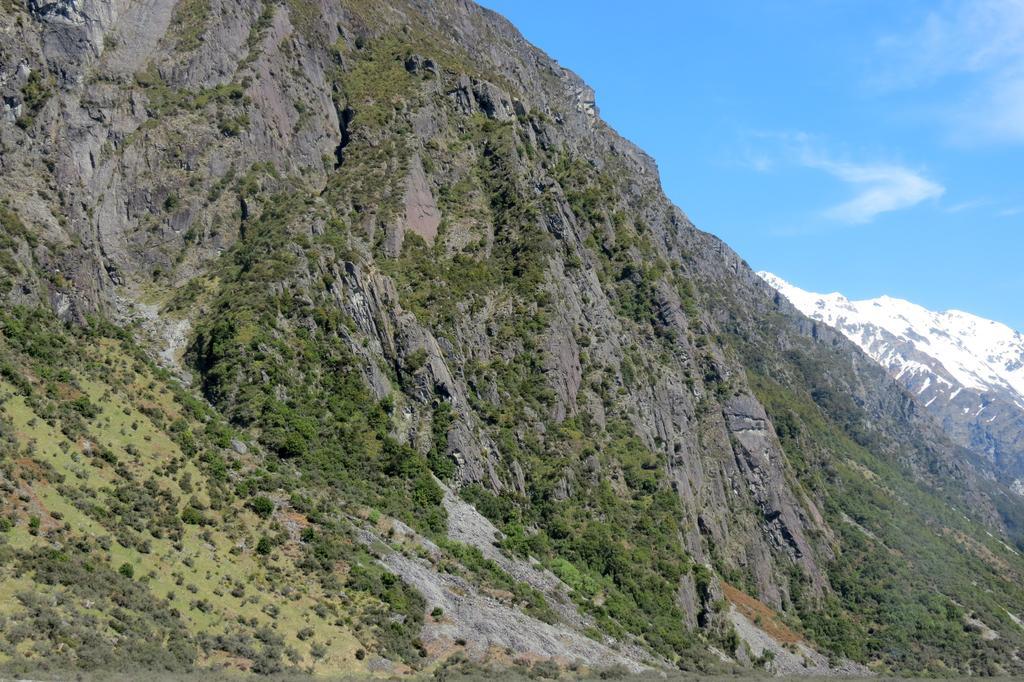In one or two sentences, can you explain what this image depicts? In this picture I can observe some plants and trees on the ground. In the background there are mountains and some clouds in the sky. 